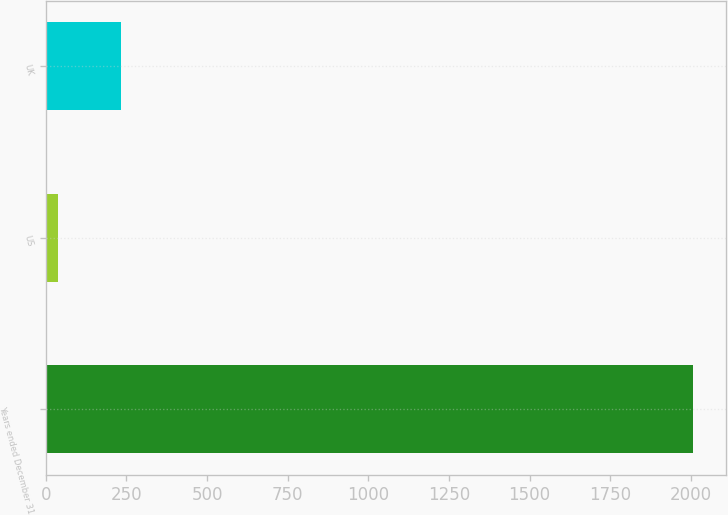Convert chart to OTSL. <chart><loc_0><loc_0><loc_500><loc_500><bar_chart><fcel>Years ended December 31<fcel>US<fcel>UK<nl><fcel>2008<fcel>37<fcel>234.1<nl></chart> 